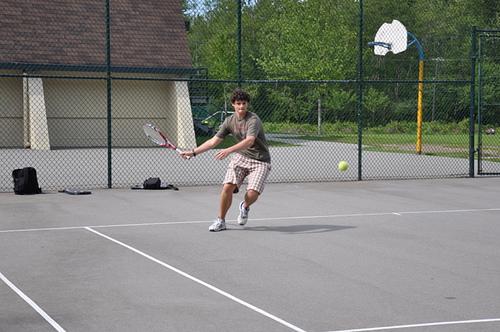Who is in the photo?
Short answer required. Man. Is he wearing basketball?
Short answer required. No. What color is the court?
Short answer required. Gray. Is this scene in a park?
Be succinct. Yes. What is the man wearing?
Quick response, please. Shorts. How many balls in the picture?
Be succinct. 1. How many people?
Be succinct. 1. Is this man playing a sport that can be played without teams?
Keep it brief. Yes. Is this man playing in a televised tournament?
Be succinct. No. Is this an older gentleman playing tennis?
Answer briefly. No. Is this court inside our outside?
Give a very brief answer. Outside. 